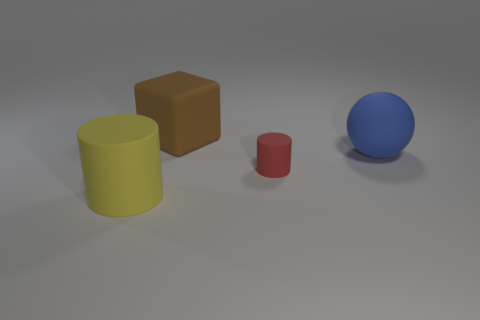Add 4 rubber cylinders. How many objects exist? 8 Subtract 1 balls. How many balls are left? 0 Subtract all balls. How many objects are left? 3 Add 2 big brown blocks. How many big brown blocks are left? 3 Add 4 large purple shiny cubes. How many large purple shiny cubes exist? 4 Subtract all red cylinders. How many cylinders are left? 1 Subtract 0 cyan blocks. How many objects are left? 4 Subtract all red spheres. Subtract all yellow cylinders. How many spheres are left? 1 Subtract all purple cylinders. How many red blocks are left? 0 Subtract all matte spheres. Subtract all small red objects. How many objects are left? 2 